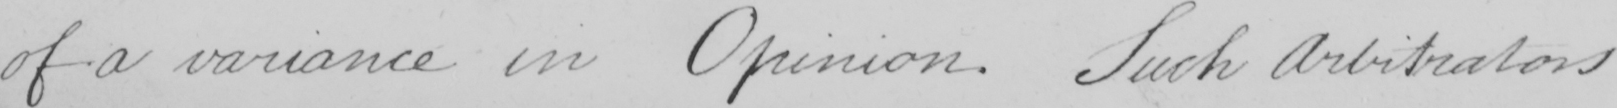What text is written in this handwritten line? of a variance in Opinion . Such Arbitrators 